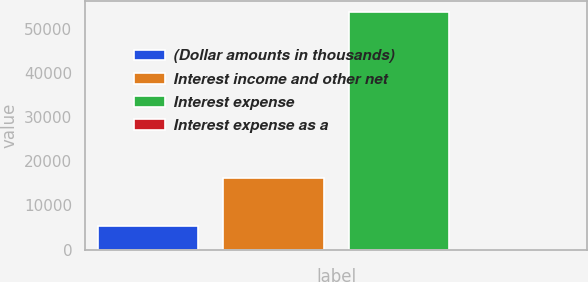Convert chart. <chart><loc_0><loc_0><loc_500><loc_500><bar_chart><fcel>(Dollar amounts in thousands)<fcel>Interest income and other net<fcel>Interest expense<fcel>Interest expense as a<nl><fcel>5383<fcel>16203<fcel>53812<fcel>2<nl></chart> 